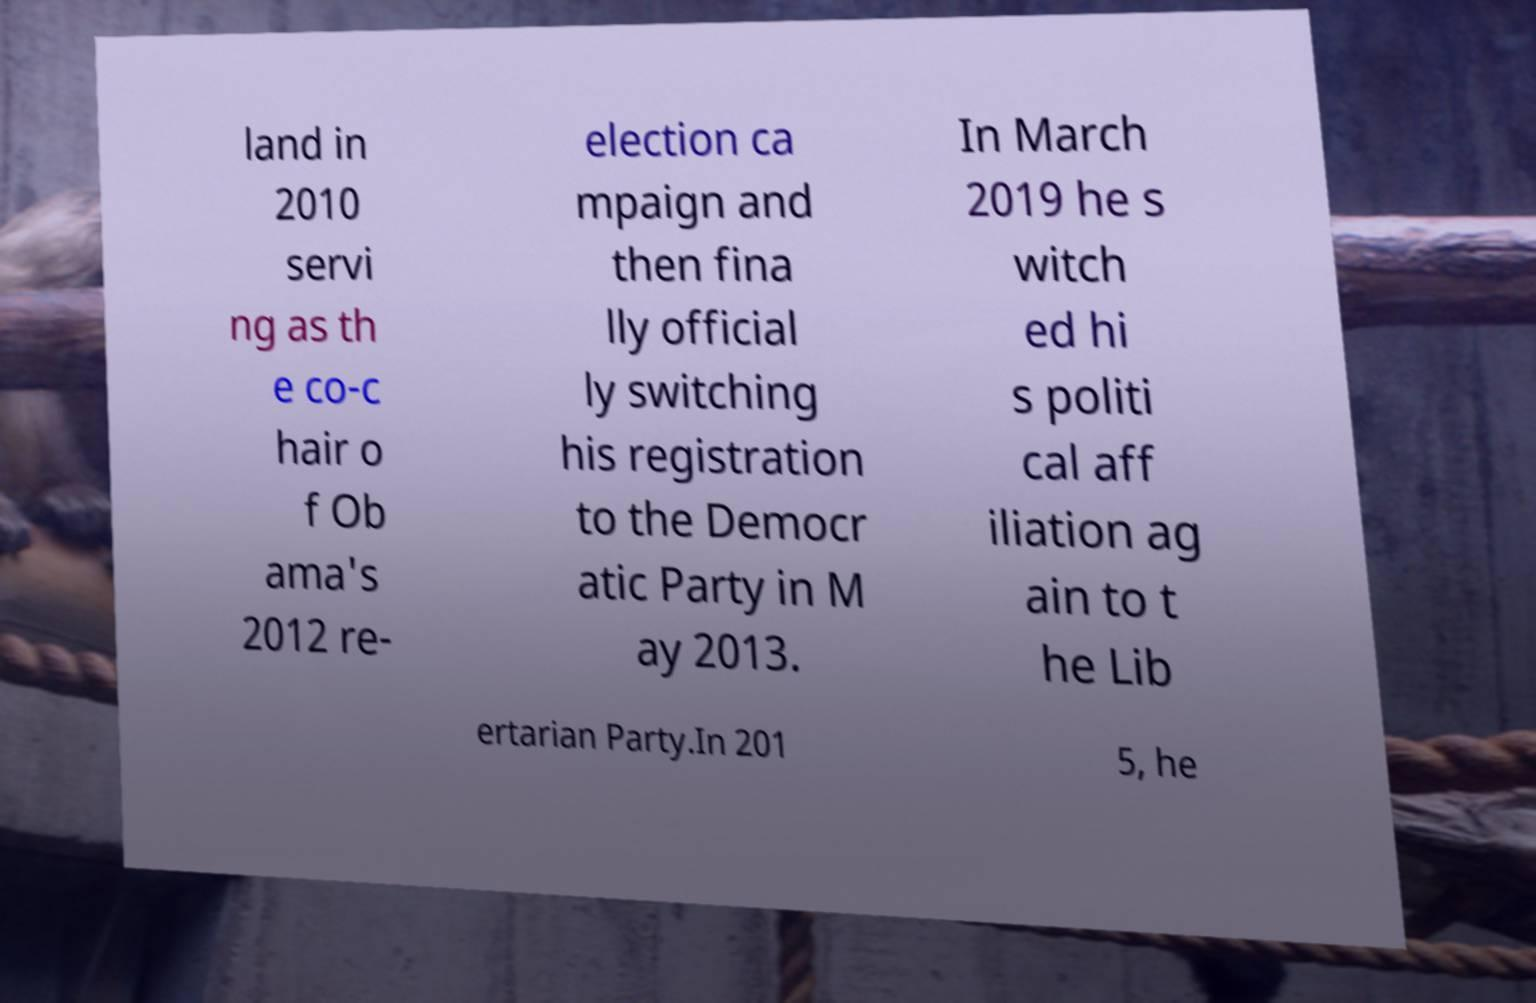Please read and relay the text visible in this image. What does it say? land in 2010 servi ng as th e co-c hair o f Ob ama's 2012 re- election ca mpaign and then fina lly official ly switching his registration to the Democr atic Party in M ay 2013. In March 2019 he s witch ed hi s politi cal aff iliation ag ain to t he Lib ertarian Party.In 201 5, he 